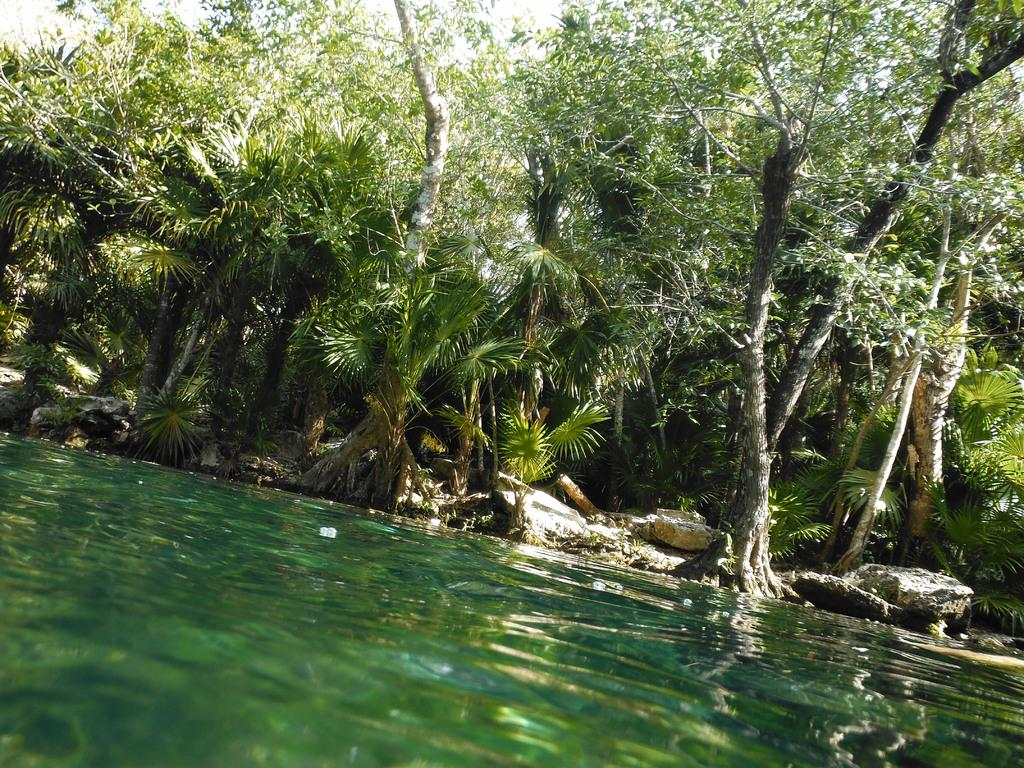What type of vegetation can be seen in the image? There are trees in the image. What part of the natural environment is visible in the image? The sky is visible in the image. What type of ground surface is present in the image? There are stones in the image. What is visible at the bottom of the image? There is water visible at the bottom of the image. How many sheep are visible in the image? There are no sheep present in the image. What color is the pencil used to draw the image? The image is not a drawing, and therefore there is no pencil used to create it. 